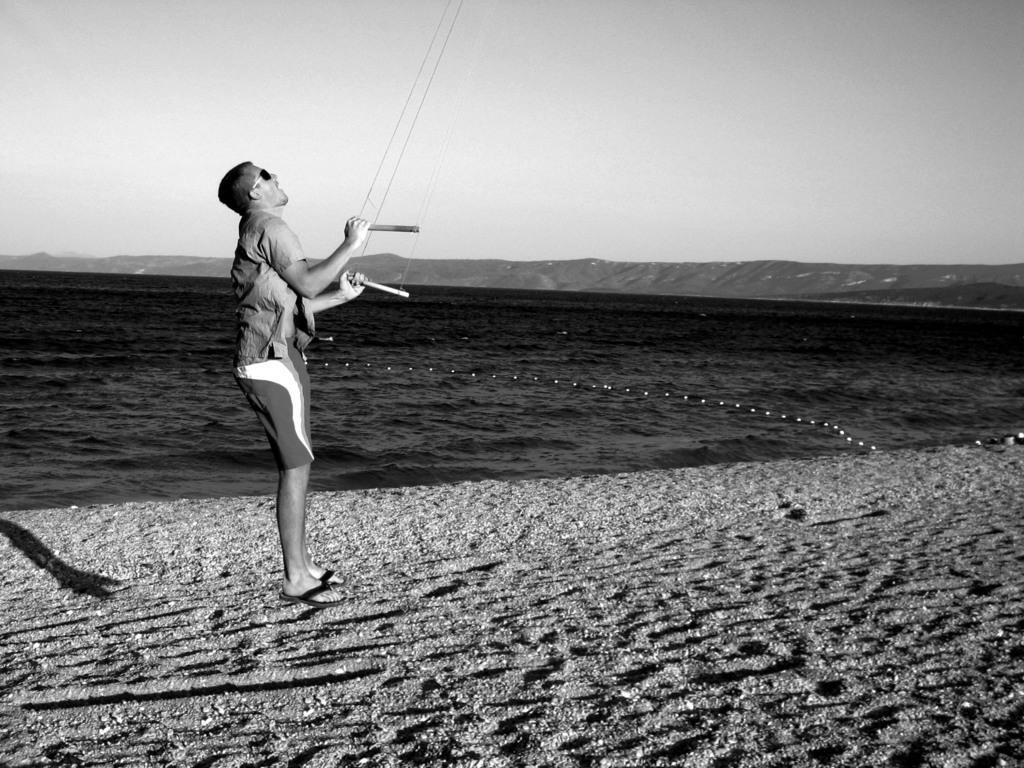Describe this image in one or two sentences. In this image we can see a man holding ropes. At the bottom there is sand. In the background there is water, hills and sky. 